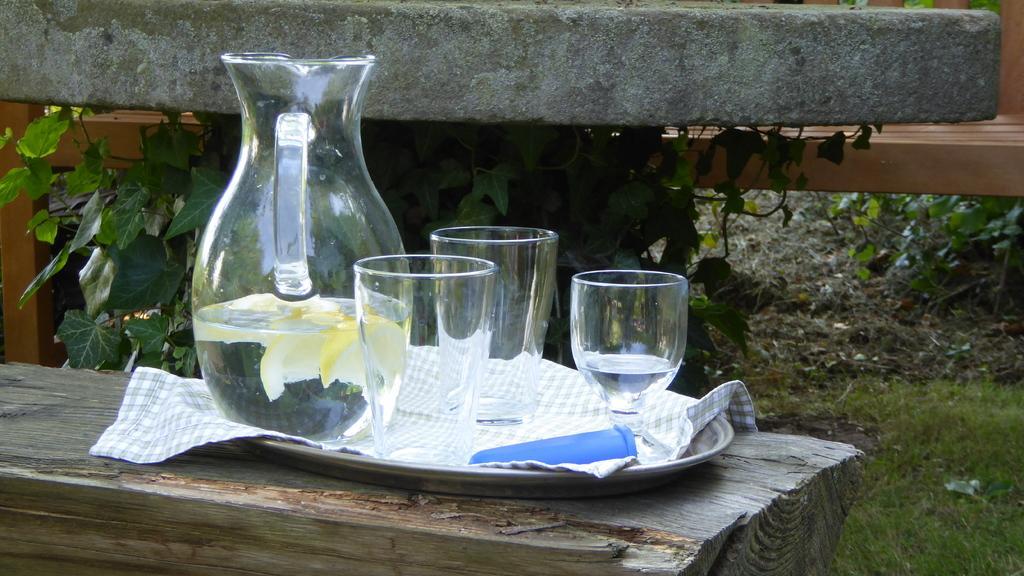Could you give a brief overview of what you see in this image? In this picture we can see a water jar with some glasses with the tray is placed on the tree trunk. Behind we can see a wooden bench and small leaves plant. 